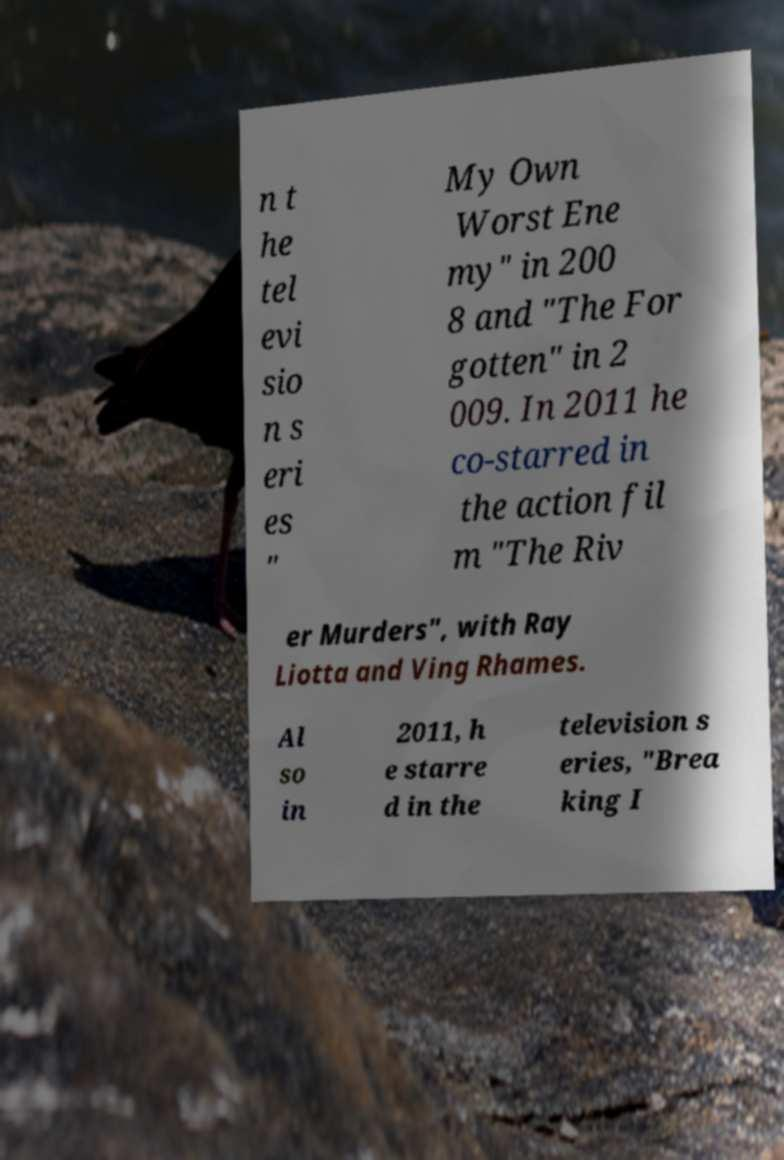Can you read and provide the text displayed in the image?This photo seems to have some interesting text. Can you extract and type it out for me? n t he tel evi sio n s eri es " My Own Worst Ene my" in 200 8 and "The For gotten" in 2 009. In 2011 he co-starred in the action fil m "The Riv er Murders", with Ray Liotta and Ving Rhames. Al so in 2011, h e starre d in the television s eries, "Brea king I 